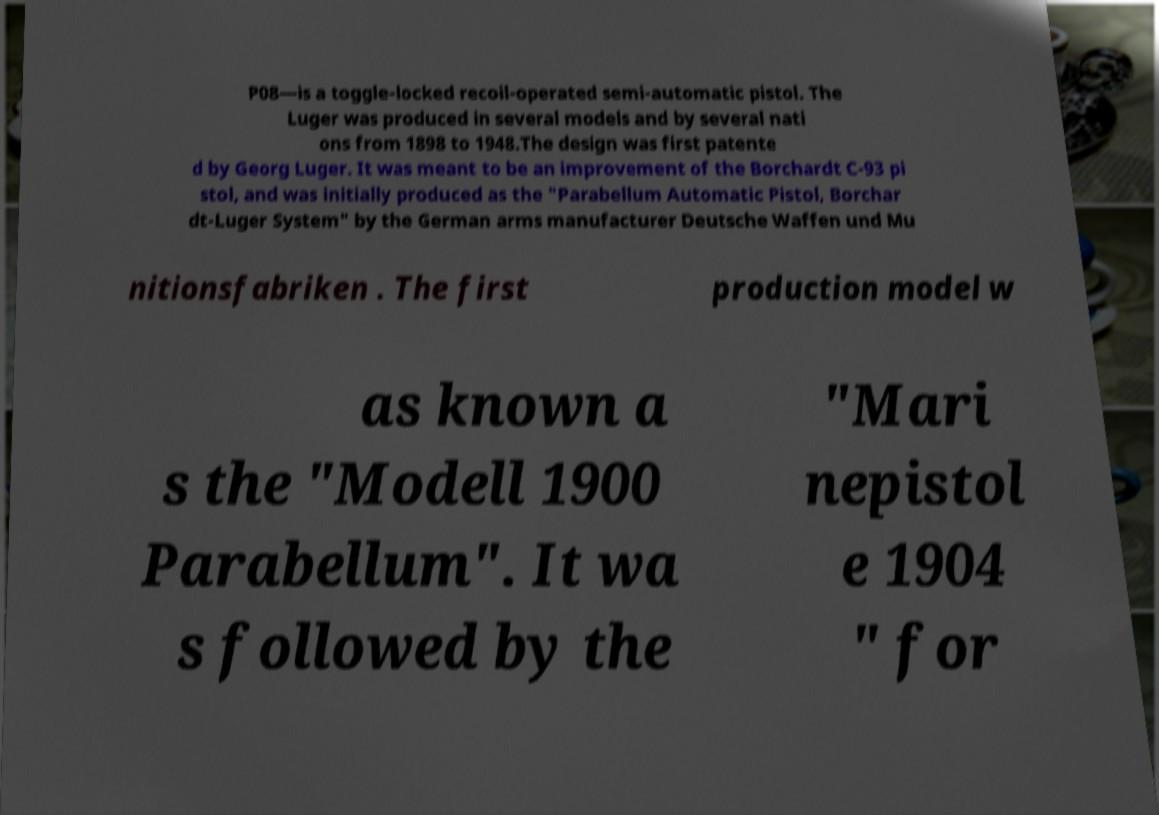Please identify and transcribe the text found in this image. P08—is a toggle-locked recoil-operated semi-automatic pistol. The Luger was produced in several models and by several nati ons from 1898 to 1948.The design was first patente d by Georg Luger. It was meant to be an improvement of the Borchardt C-93 pi stol, and was initially produced as the "Parabellum Automatic Pistol, Borchar dt-Luger System" by the German arms manufacturer Deutsche Waffen und Mu nitionsfabriken . The first production model w as known a s the "Modell 1900 Parabellum". It wa s followed by the "Mari nepistol e 1904 " for 